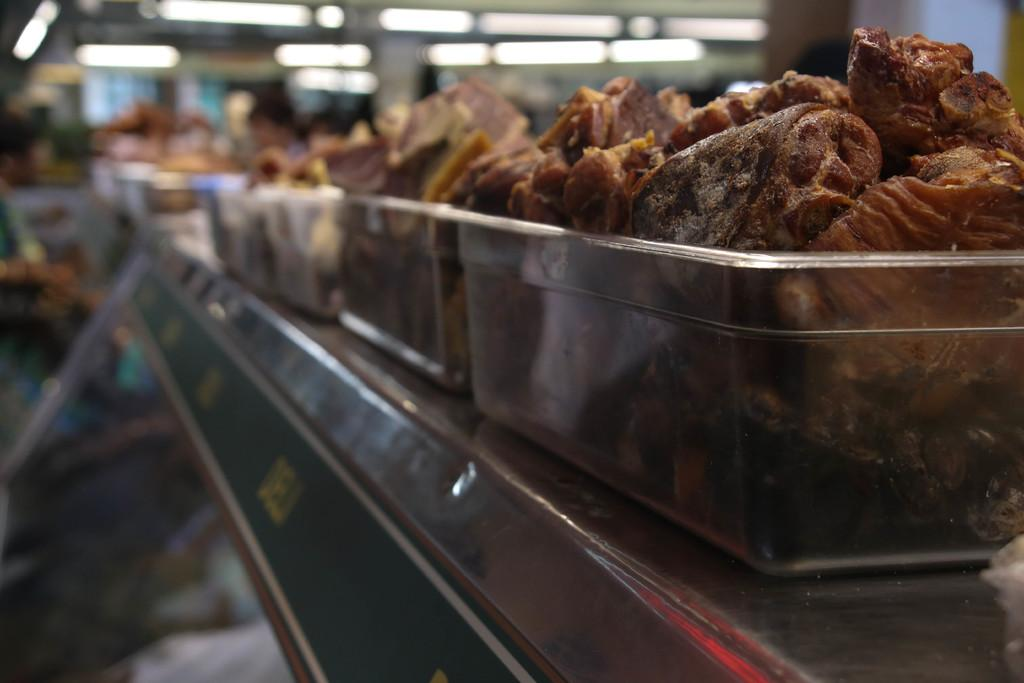What type of food items are in the container in the image? There are snacks in a container in the image. Where is the container located? The container is on a table. What type of lighting is visible in the image? There are ceiling lights visible in the image. What country is the uncle from in the image? There is no uncle present in the image, so it is not possible to determine the country he might be from. 